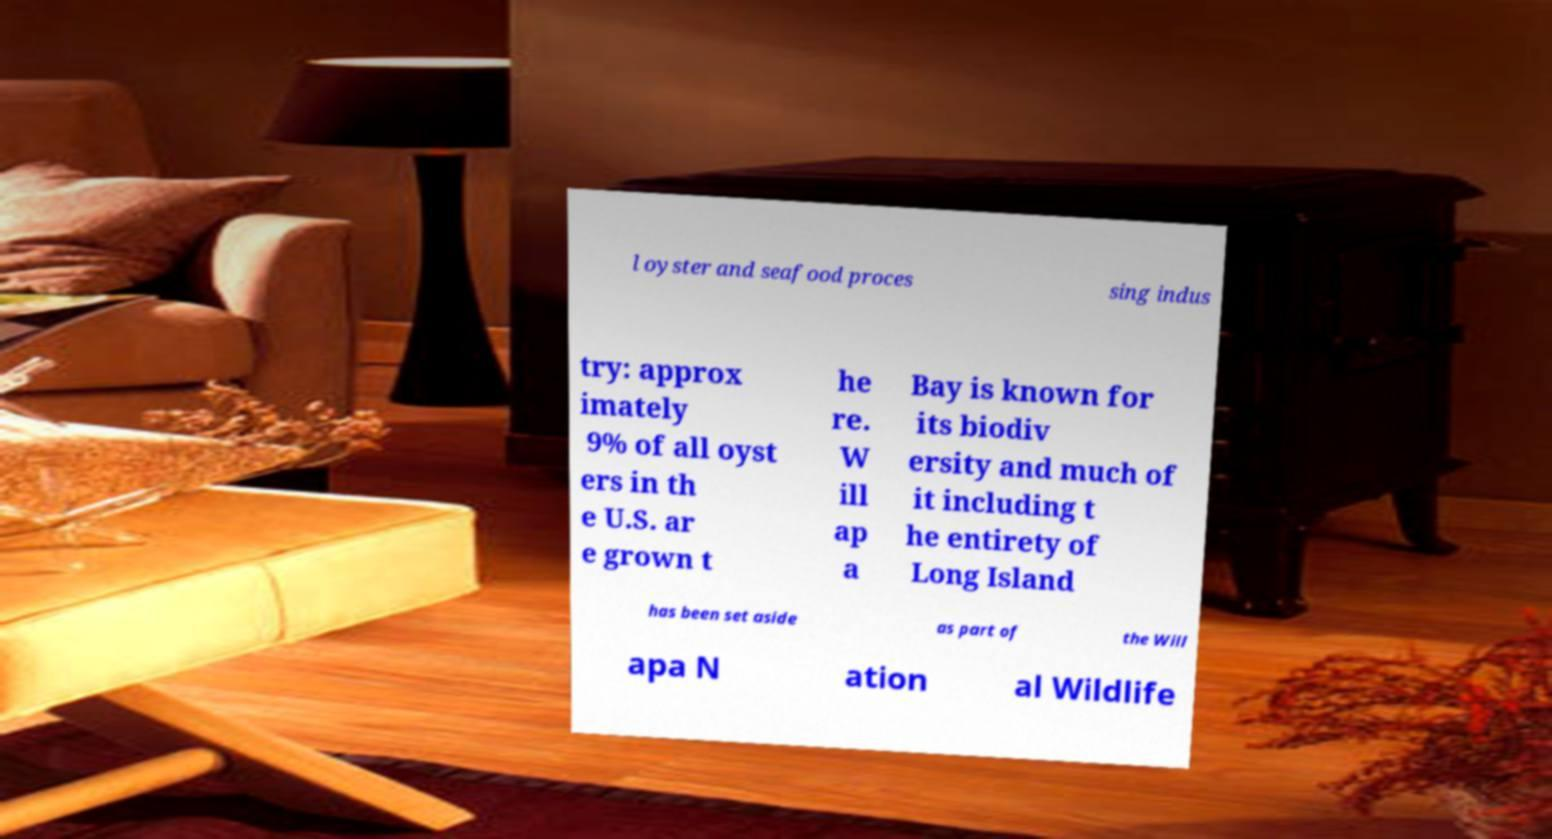Could you assist in decoding the text presented in this image and type it out clearly? l oyster and seafood proces sing indus try: approx imately 9% of all oyst ers in th e U.S. ar e grown t he re. W ill ap a Bay is known for its biodiv ersity and much of it including t he entirety of Long Island has been set aside as part of the Will apa N ation al Wildlife 